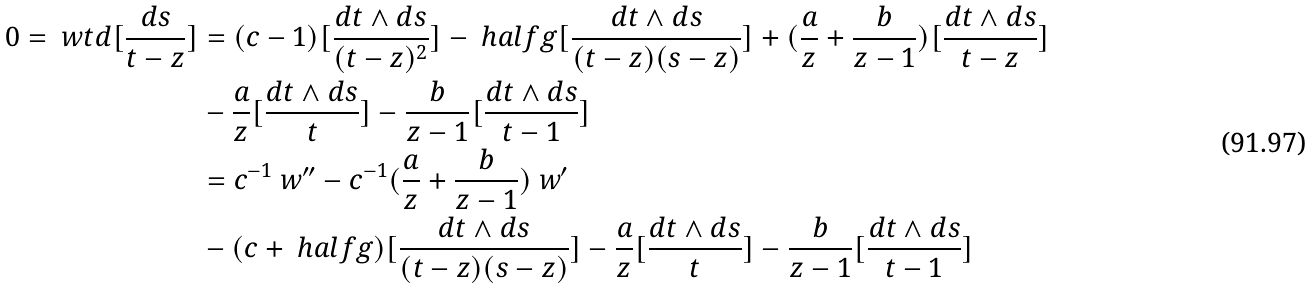<formula> <loc_0><loc_0><loc_500><loc_500>0 = \ w t d [ \frac { d s } { t - z } ] & = ( c - 1 ) [ \frac { d t \wedge d s } { ( t - z ) ^ { 2 } } ] - \ h a l f { g } [ \frac { d t \wedge d s } { ( t - z ) ( s - z ) } ] + ( \frac { a } { z } + \frac { b } { z - 1 } ) [ \frac { d t \wedge d s } { t - z } ] \\ & - \frac { a } { z } [ \frac { d t \wedge d s } { t } ] - \frac { b } { z - 1 } [ \frac { d t \wedge d s } { t - 1 } ] \\ & = c ^ { - 1 } \ w ^ { \prime \prime } - c ^ { - 1 } ( \frac { a } { z } + \frac { b } { z - 1 } ) \ w ^ { \prime } \\ & - ( c + \ h a l f { g } ) [ \frac { d t \wedge d s } { ( t - z ) ( s - z ) } ] - \frac { a } { z } [ \frac { d t \wedge d s } { t } ] - \frac { b } { z - 1 } [ \frac { d t \wedge d s } { t - 1 } ]</formula> 